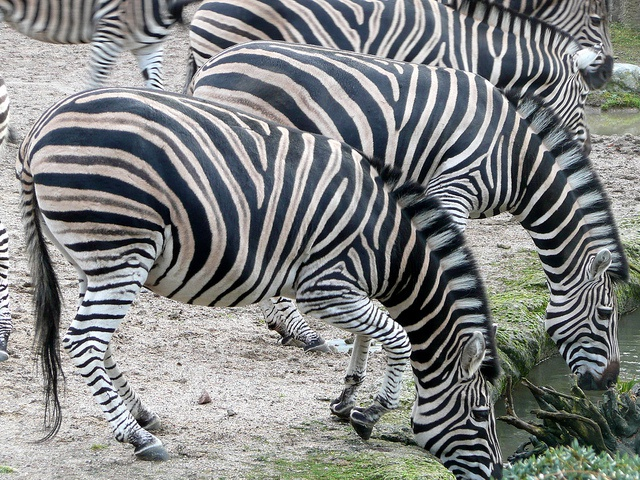Describe the objects in this image and their specific colors. I can see zebra in darkgray, black, gray, and lightgray tones, zebra in darkgray, gray, black, and lightgray tones, zebra in darkgray, lightgray, gray, and black tones, zebra in darkgray, gray, lightgray, and black tones, and zebra in darkgray, gray, black, and lightgray tones in this image. 